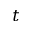Convert formula to latex. <formula><loc_0><loc_0><loc_500><loc_500>t</formula> 